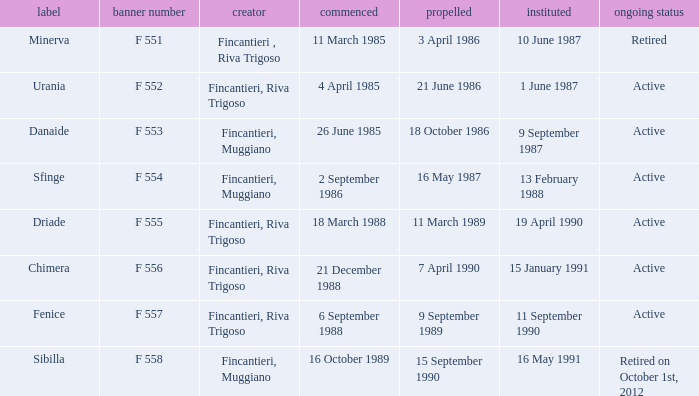What is the name of the builder who launched in danaide 18 October 1986. 